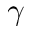<formula> <loc_0><loc_0><loc_500><loc_500>\gamma</formula> 